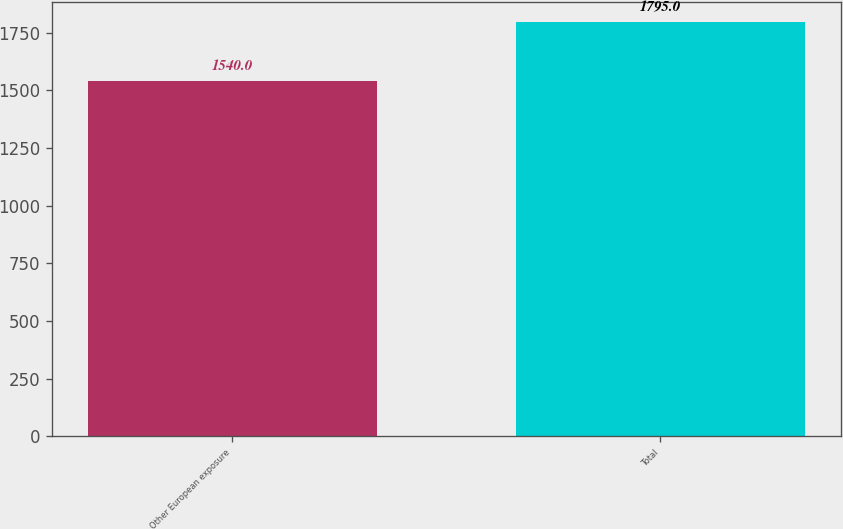Convert chart to OTSL. <chart><loc_0><loc_0><loc_500><loc_500><bar_chart><fcel>Other European exposure<fcel>Total<nl><fcel>1540<fcel>1795<nl></chart> 